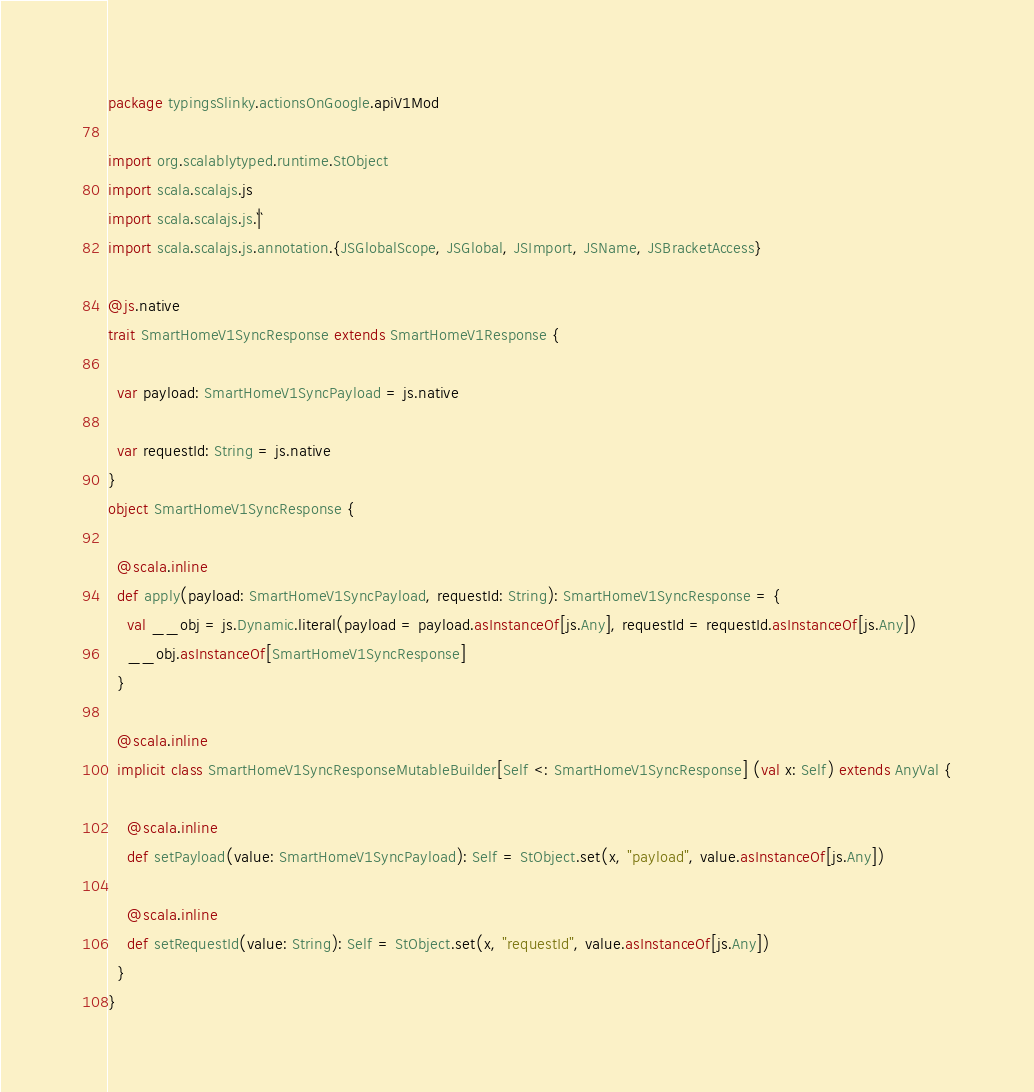<code> <loc_0><loc_0><loc_500><loc_500><_Scala_>package typingsSlinky.actionsOnGoogle.apiV1Mod

import org.scalablytyped.runtime.StObject
import scala.scalajs.js
import scala.scalajs.js.`|`
import scala.scalajs.js.annotation.{JSGlobalScope, JSGlobal, JSImport, JSName, JSBracketAccess}

@js.native
trait SmartHomeV1SyncResponse extends SmartHomeV1Response {
  
  var payload: SmartHomeV1SyncPayload = js.native
  
  var requestId: String = js.native
}
object SmartHomeV1SyncResponse {
  
  @scala.inline
  def apply(payload: SmartHomeV1SyncPayload, requestId: String): SmartHomeV1SyncResponse = {
    val __obj = js.Dynamic.literal(payload = payload.asInstanceOf[js.Any], requestId = requestId.asInstanceOf[js.Any])
    __obj.asInstanceOf[SmartHomeV1SyncResponse]
  }
  
  @scala.inline
  implicit class SmartHomeV1SyncResponseMutableBuilder[Self <: SmartHomeV1SyncResponse] (val x: Self) extends AnyVal {
    
    @scala.inline
    def setPayload(value: SmartHomeV1SyncPayload): Self = StObject.set(x, "payload", value.asInstanceOf[js.Any])
    
    @scala.inline
    def setRequestId(value: String): Self = StObject.set(x, "requestId", value.asInstanceOf[js.Any])
  }
}
</code> 